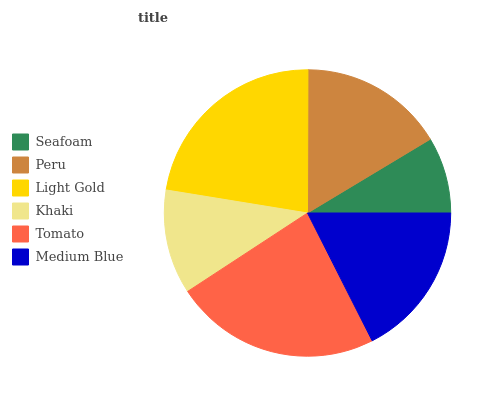Is Seafoam the minimum?
Answer yes or no. Yes. Is Tomato the maximum?
Answer yes or no. Yes. Is Peru the minimum?
Answer yes or no. No. Is Peru the maximum?
Answer yes or no. No. Is Peru greater than Seafoam?
Answer yes or no. Yes. Is Seafoam less than Peru?
Answer yes or no. Yes. Is Seafoam greater than Peru?
Answer yes or no. No. Is Peru less than Seafoam?
Answer yes or no. No. Is Medium Blue the high median?
Answer yes or no. Yes. Is Peru the low median?
Answer yes or no. Yes. Is Peru the high median?
Answer yes or no. No. Is Seafoam the low median?
Answer yes or no. No. 